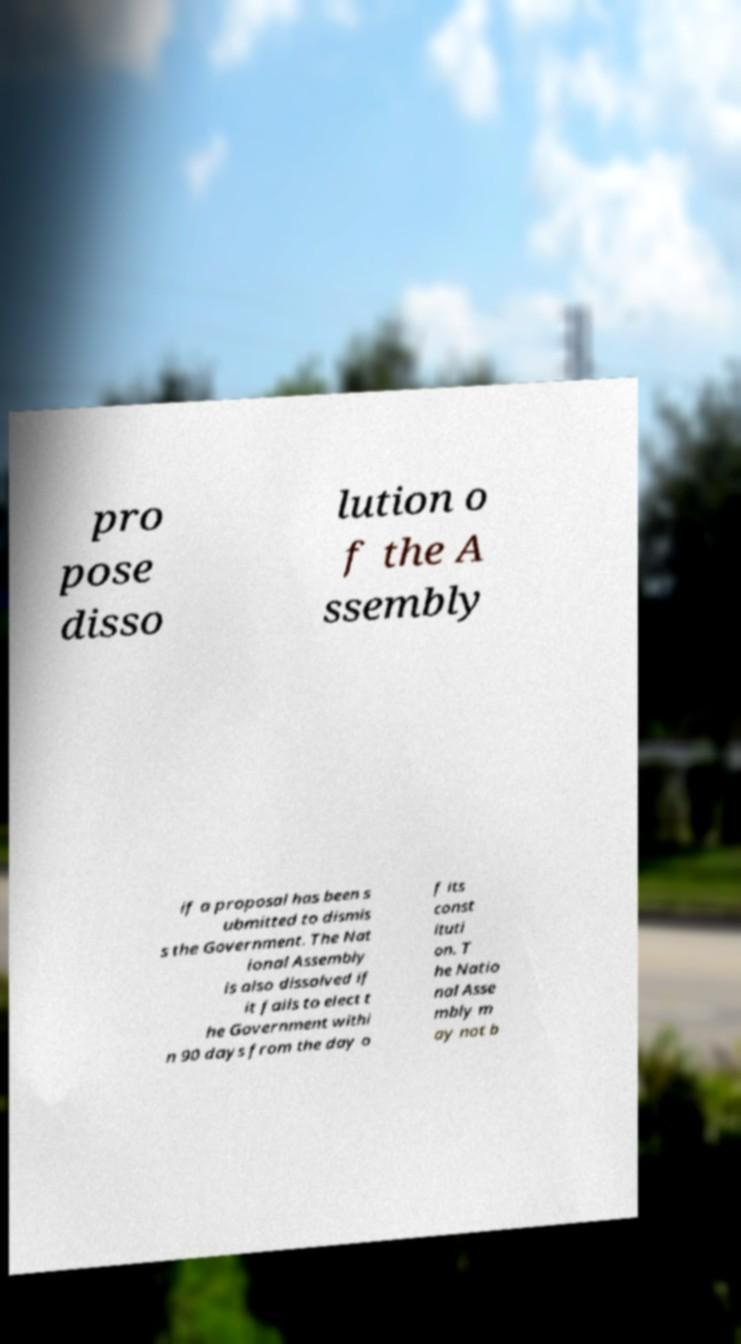What messages or text are displayed in this image? I need them in a readable, typed format. pro pose disso lution o f the A ssembly if a proposal has been s ubmitted to dismis s the Government. The Nat ional Assembly is also dissolved if it fails to elect t he Government withi n 90 days from the day o f its const ituti on. T he Natio nal Asse mbly m ay not b 